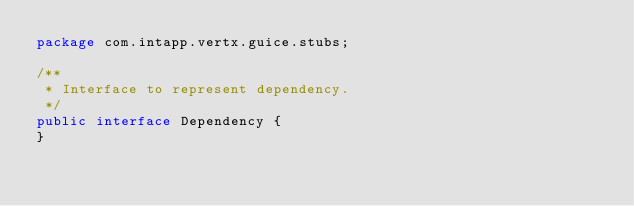<code> <loc_0><loc_0><loc_500><loc_500><_Java_>package com.intapp.vertx.guice.stubs;

/**
 * Interface to represent dependency.
 */
public interface Dependency {
}
</code> 